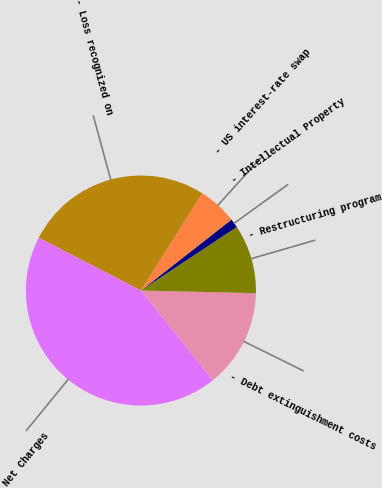Convert chart. <chart><loc_0><loc_0><loc_500><loc_500><pie_chart><fcel>- Debt extinguishment costs<fcel>- Restructuring program<fcel>- Intellectual Property<fcel>- US interest-rate swap<fcel>- Loss recognized on<fcel>Net Charges<nl><fcel>13.88%<fcel>9.68%<fcel>1.26%<fcel>5.47%<fcel>26.37%<fcel>43.34%<nl></chart> 